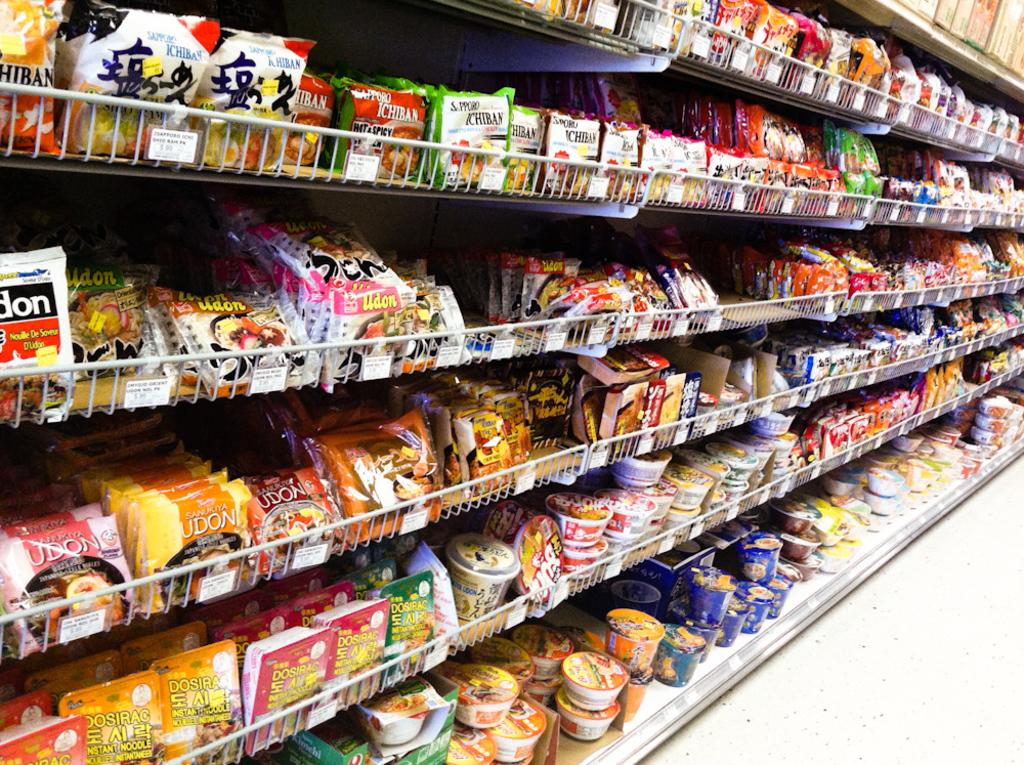What kind of noodles are on the fourth row from the top?
Keep it short and to the point. Udon. What snack is on the second shelf?
Give a very brief answer. Unanswerable. 